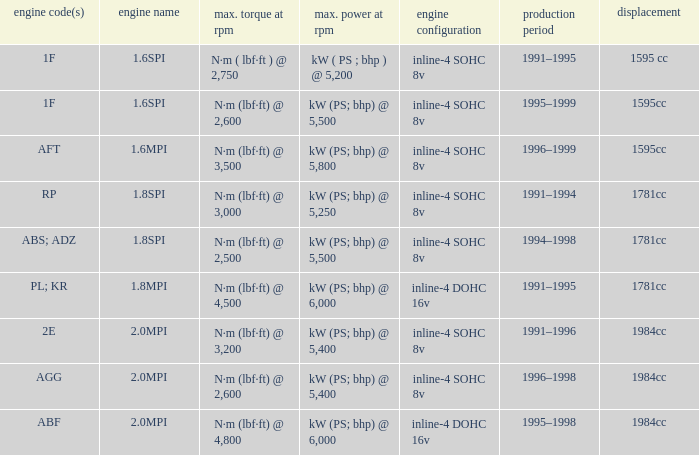Could you help me parse every detail presented in this table? {'header': ['engine code(s)', 'engine name', 'max. torque at rpm', 'max. power at rpm', 'engine configuration', 'production period', 'displacement'], 'rows': [['1F', '1.6SPI', 'N·m ( lbf·ft ) @ 2,750', 'kW ( PS ; bhp ) @ 5,200', 'inline-4 SOHC 8v', '1991–1995', '1595 cc'], ['1F', '1.6SPI', 'N·m (lbf·ft) @ 2,600', 'kW (PS; bhp) @ 5,500', 'inline-4 SOHC 8v', '1995–1999', '1595cc'], ['AFT', '1.6MPI', 'N·m (lbf·ft) @ 3,500', 'kW (PS; bhp) @ 5,800', 'inline-4 SOHC 8v', '1996–1999', '1595cc'], ['RP', '1.8SPI', 'N·m (lbf·ft) @ 3,000', 'kW (PS; bhp) @ 5,250', 'inline-4 SOHC 8v', '1991–1994', '1781cc'], ['ABS; ADZ', '1.8SPI', 'N·m (lbf·ft) @ 2,500', 'kW (PS; bhp) @ 5,500', 'inline-4 SOHC 8v', '1994–1998', '1781cc'], ['PL; KR', '1.8MPI', 'N·m (lbf·ft) @ 4,500', 'kW (PS; bhp) @ 6,000', 'inline-4 DOHC 16v', '1991–1995', '1781cc'], ['2E', '2.0MPI', 'N·m (lbf·ft) @ 3,200', 'kW (PS; bhp) @ 5,400', 'inline-4 SOHC 8v', '1991–1996', '1984cc'], ['AGG', '2.0MPI', 'N·m (lbf·ft) @ 2,600', 'kW (PS; bhp) @ 5,400', 'inline-4 SOHC 8v', '1996–1998', '1984cc'], ['ABF', '2.0MPI', 'N·m (lbf·ft) @ 4,800', 'kW (PS; bhp) @ 6,000', 'inline-4 DOHC 16v', '1995–1998', '1984cc']]} What is the maximum power of engine code 2e? Kw (ps; bhp) @ 5,400. 